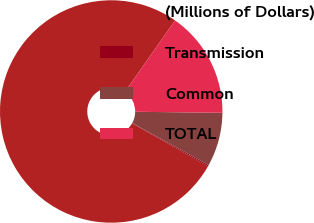<chart> <loc_0><loc_0><loc_500><loc_500><pie_chart><fcel>(Millions of Dollars)<fcel>Transmission<fcel>Common<fcel>TOTAL<nl><fcel>76.53%<fcel>0.19%<fcel>7.82%<fcel>15.46%<nl></chart> 